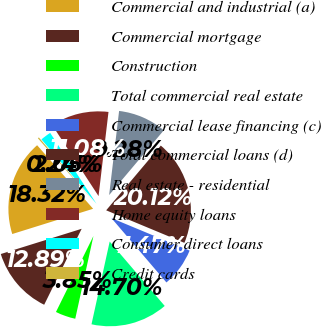Convert chart to OTSL. <chart><loc_0><loc_0><loc_500><loc_500><pie_chart><fcel>Commercial and industrial (a)<fcel>Commercial mortgage<fcel>Construction<fcel>Total commercial real estate<fcel>Commercial lease financing (c)<fcel>Total commercial loans (d)<fcel>Real estate - residential<fcel>Home equity loans<fcel>Consumer direct loans<fcel>Credit cards<nl><fcel>18.32%<fcel>12.89%<fcel>3.85%<fcel>14.7%<fcel>7.47%<fcel>20.12%<fcel>9.28%<fcel>11.08%<fcel>2.05%<fcel>0.24%<nl></chart> 